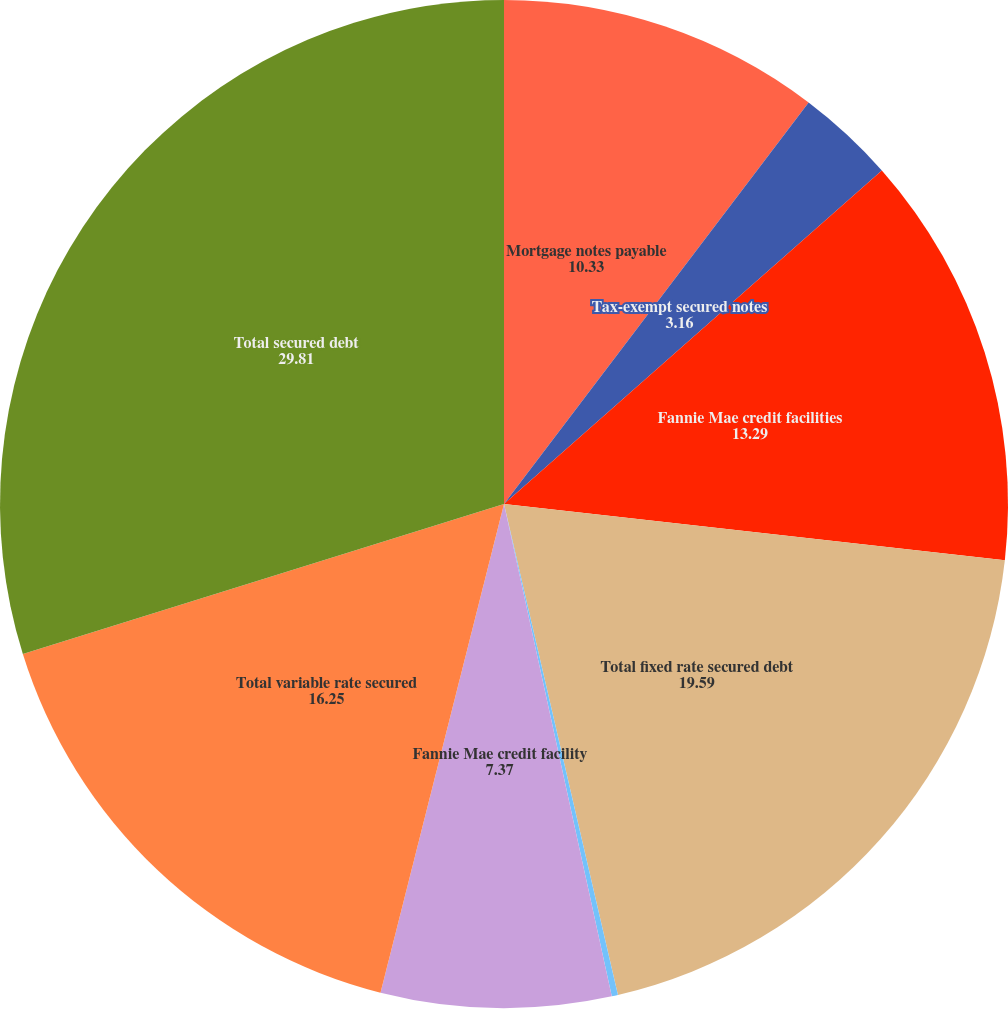<chart> <loc_0><loc_0><loc_500><loc_500><pie_chart><fcel>Mortgage notes payable<fcel>Tax-exempt secured notes<fcel>Fannie Mae credit facilities<fcel>Total fixed rate secured debt<fcel>Tax-exempt secured note<fcel>Fannie Mae credit facility<fcel>Total variable rate secured<fcel>Total secured debt<nl><fcel>10.33%<fcel>3.16%<fcel>13.29%<fcel>19.59%<fcel>0.2%<fcel>7.37%<fcel>16.25%<fcel>29.81%<nl></chart> 